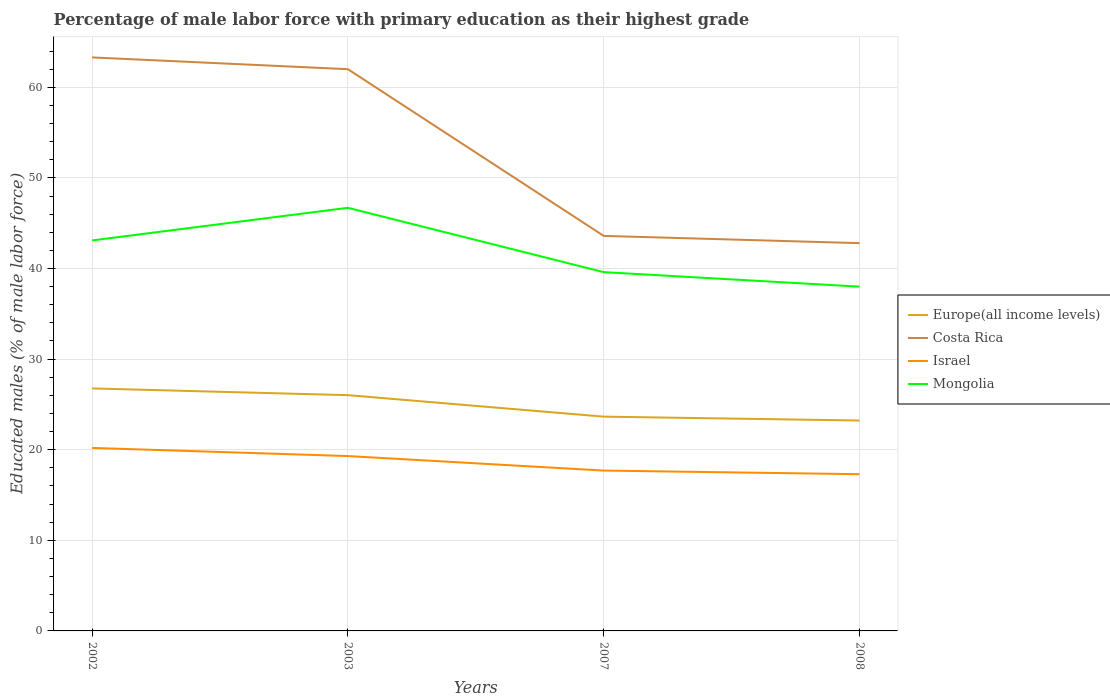How many different coloured lines are there?
Provide a short and direct response. 4. Across all years, what is the maximum percentage of male labor force with primary education in Costa Rica?
Your response must be concise. 42.8. In which year was the percentage of male labor force with primary education in Mongolia maximum?
Ensure brevity in your answer.  2008. What is the total percentage of male labor force with primary education in Mongolia in the graph?
Offer a very short reply. -3.6. What is the difference between the highest and the second highest percentage of male labor force with primary education in Israel?
Make the answer very short. 2.9. Is the percentage of male labor force with primary education in Israel strictly greater than the percentage of male labor force with primary education in Costa Rica over the years?
Provide a short and direct response. Yes. How many years are there in the graph?
Offer a terse response. 4. What is the difference between two consecutive major ticks on the Y-axis?
Provide a short and direct response. 10. Are the values on the major ticks of Y-axis written in scientific E-notation?
Your answer should be compact. No. Does the graph contain any zero values?
Your response must be concise. No. Does the graph contain grids?
Provide a short and direct response. Yes. How many legend labels are there?
Ensure brevity in your answer.  4. What is the title of the graph?
Your answer should be very brief. Percentage of male labor force with primary education as their highest grade. Does "Europe(developing only)" appear as one of the legend labels in the graph?
Offer a very short reply. No. What is the label or title of the Y-axis?
Keep it short and to the point. Educated males (% of male labor force). What is the Educated males (% of male labor force) of Europe(all income levels) in 2002?
Make the answer very short. 26.77. What is the Educated males (% of male labor force) in Costa Rica in 2002?
Your response must be concise. 63.3. What is the Educated males (% of male labor force) in Israel in 2002?
Your answer should be very brief. 20.2. What is the Educated males (% of male labor force) of Mongolia in 2002?
Offer a very short reply. 43.1. What is the Educated males (% of male labor force) in Europe(all income levels) in 2003?
Give a very brief answer. 26.02. What is the Educated males (% of male labor force) in Costa Rica in 2003?
Provide a short and direct response. 62. What is the Educated males (% of male labor force) of Israel in 2003?
Give a very brief answer. 19.3. What is the Educated males (% of male labor force) in Mongolia in 2003?
Offer a terse response. 46.7. What is the Educated males (% of male labor force) in Europe(all income levels) in 2007?
Provide a succinct answer. 23.65. What is the Educated males (% of male labor force) in Costa Rica in 2007?
Give a very brief answer. 43.6. What is the Educated males (% of male labor force) in Israel in 2007?
Your response must be concise. 17.7. What is the Educated males (% of male labor force) in Mongolia in 2007?
Provide a short and direct response. 39.6. What is the Educated males (% of male labor force) in Europe(all income levels) in 2008?
Keep it short and to the point. 23.22. What is the Educated males (% of male labor force) of Costa Rica in 2008?
Your answer should be compact. 42.8. What is the Educated males (% of male labor force) of Israel in 2008?
Make the answer very short. 17.3. What is the Educated males (% of male labor force) of Mongolia in 2008?
Give a very brief answer. 38. Across all years, what is the maximum Educated males (% of male labor force) of Europe(all income levels)?
Provide a short and direct response. 26.77. Across all years, what is the maximum Educated males (% of male labor force) in Costa Rica?
Offer a very short reply. 63.3. Across all years, what is the maximum Educated males (% of male labor force) of Israel?
Provide a succinct answer. 20.2. Across all years, what is the maximum Educated males (% of male labor force) of Mongolia?
Offer a very short reply. 46.7. Across all years, what is the minimum Educated males (% of male labor force) of Europe(all income levels)?
Give a very brief answer. 23.22. Across all years, what is the minimum Educated males (% of male labor force) in Costa Rica?
Your answer should be compact. 42.8. Across all years, what is the minimum Educated males (% of male labor force) in Israel?
Provide a succinct answer. 17.3. Across all years, what is the minimum Educated males (% of male labor force) of Mongolia?
Provide a short and direct response. 38. What is the total Educated males (% of male labor force) of Europe(all income levels) in the graph?
Ensure brevity in your answer.  99.66. What is the total Educated males (% of male labor force) of Costa Rica in the graph?
Your response must be concise. 211.7. What is the total Educated males (% of male labor force) of Israel in the graph?
Provide a short and direct response. 74.5. What is the total Educated males (% of male labor force) in Mongolia in the graph?
Your answer should be compact. 167.4. What is the difference between the Educated males (% of male labor force) in Europe(all income levels) in 2002 and that in 2003?
Your response must be concise. 0.74. What is the difference between the Educated males (% of male labor force) in Mongolia in 2002 and that in 2003?
Your answer should be compact. -3.6. What is the difference between the Educated males (% of male labor force) in Europe(all income levels) in 2002 and that in 2007?
Offer a terse response. 3.11. What is the difference between the Educated males (% of male labor force) of Costa Rica in 2002 and that in 2007?
Give a very brief answer. 19.7. What is the difference between the Educated males (% of male labor force) of Israel in 2002 and that in 2007?
Provide a short and direct response. 2.5. What is the difference between the Educated males (% of male labor force) of Mongolia in 2002 and that in 2007?
Give a very brief answer. 3.5. What is the difference between the Educated males (% of male labor force) in Europe(all income levels) in 2002 and that in 2008?
Provide a short and direct response. 3.54. What is the difference between the Educated males (% of male labor force) of Costa Rica in 2002 and that in 2008?
Keep it short and to the point. 20.5. What is the difference between the Educated males (% of male labor force) in Mongolia in 2002 and that in 2008?
Offer a very short reply. 5.1. What is the difference between the Educated males (% of male labor force) in Europe(all income levels) in 2003 and that in 2007?
Keep it short and to the point. 2.37. What is the difference between the Educated males (% of male labor force) of Mongolia in 2003 and that in 2007?
Offer a very short reply. 7.1. What is the difference between the Educated males (% of male labor force) in Europe(all income levels) in 2003 and that in 2008?
Provide a short and direct response. 2.8. What is the difference between the Educated males (% of male labor force) in Mongolia in 2003 and that in 2008?
Your answer should be very brief. 8.7. What is the difference between the Educated males (% of male labor force) of Europe(all income levels) in 2007 and that in 2008?
Offer a terse response. 0.43. What is the difference between the Educated males (% of male labor force) in Europe(all income levels) in 2002 and the Educated males (% of male labor force) in Costa Rica in 2003?
Ensure brevity in your answer.  -35.23. What is the difference between the Educated males (% of male labor force) of Europe(all income levels) in 2002 and the Educated males (% of male labor force) of Israel in 2003?
Make the answer very short. 7.47. What is the difference between the Educated males (% of male labor force) of Europe(all income levels) in 2002 and the Educated males (% of male labor force) of Mongolia in 2003?
Offer a very short reply. -19.93. What is the difference between the Educated males (% of male labor force) in Costa Rica in 2002 and the Educated males (% of male labor force) in Mongolia in 2003?
Make the answer very short. 16.6. What is the difference between the Educated males (% of male labor force) in Israel in 2002 and the Educated males (% of male labor force) in Mongolia in 2003?
Your answer should be very brief. -26.5. What is the difference between the Educated males (% of male labor force) of Europe(all income levels) in 2002 and the Educated males (% of male labor force) of Costa Rica in 2007?
Your response must be concise. -16.83. What is the difference between the Educated males (% of male labor force) in Europe(all income levels) in 2002 and the Educated males (% of male labor force) in Israel in 2007?
Make the answer very short. 9.07. What is the difference between the Educated males (% of male labor force) of Europe(all income levels) in 2002 and the Educated males (% of male labor force) of Mongolia in 2007?
Your answer should be very brief. -12.83. What is the difference between the Educated males (% of male labor force) of Costa Rica in 2002 and the Educated males (% of male labor force) of Israel in 2007?
Your answer should be compact. 45.6. What is the difference between the Educated males (% of male labor force) in Costa Rica in 2002 and the Educated males (% of male labor force) in Mongolia in 2007?
Ensure brevity in your answer.  23.7. What is the difference between the Educated males (% of male labor force) in Israel in 2002 and the Educated males (% of male labor force) in Mongolia in 2007?
Your answer should be compact. -19.4. What is the difference between the Educated males (% of male labor force) in Europe(all income levels) in 2002 and the Educated males (% of male labor force) in Costa Rica in 2008?
Keep it short and to the point. -16.03. What is the difference between the Educated males (% of male labor force) in Europe(all income levels) in 2002 and the Educated males (% of male labor force) in Israel in 2008?
Ensure brevity in your answer.  9.47. What is the difference between the Educated males (% of male labor force) of Europe(all income levels) in 2002 and the Educated males (% of male labor force) of Mongolia in 2008?
Offer a terse response. -11.23. What is the difference between the Educated males (% of male labor force) of Costa Rica in 2002 and the Educated males (% of male labor force) of Israel in 2008?
Make the answer very short. 46. What is the difference between the Educated males (% of male labor force) of Costa Rica in 2002 and the Educated males (% of male labor force) of Mongolia in 2008?
Make the answer very short. 25.3. What is the difference between the Educated males (% of male labor force) of Israel in 2002 and the Educated males (% of male labor force) of Mongolia in 2008?
Ensure brevity in your answer.  -17.8. What is the difference between the Educated males (% of male labor force) in Europe(all income levels) in 2003 and the Educated males (% of male labor force) in Costa Rica in 2007?
Make the answer very short. -17.58. What is the difference between the Educated males (% of male labor force) of Europe(all income levels) in 2003 and the Educated males (% of male labor force) of Israel in 2007?
Make the answer very short. 8.32. What is the difference between the Educated males (% of male labor force) in Europe(all income levels) in 2003 and the Educated males (% of male labor force) in Mongolia in 2007?
Offer a very short reply. -13.58. What is the difference between the Educated males (% of male labor force) in Costa Rica in 2003 and the Educated males (% of male labor force) in Israel in 2007?
Make the answer very short. 44.3. What is the difference between the Educated males (% of male labor force) in Costa Rica in 2003 and the Educated males (% of male labor force) in Mongolia in 2007?
Make the answer very short. 22.4. What is the difference between the Educated males (% of male labor force) of Israel in 2003 and the Educated males (% of male labor force) of Mongolia in 2007?
Provide a succinct answer. -20.3. What is the difference between the Educated males (% of male labor force) of Europe(all income levels) in 2003 and the Educated males (% of male labor force) of Costa Rica in 2008?
Give a very brief answer. -16.78. What is the difference between the Educated males (% of male labor force) in Europe(all income levels) in 2003 and the Educated males (% of male labor force) in Israel in 2008?
Your answer should be compact. 8.72. What is the difference between the Educated males (% of male labor force) of Europe(all income levels) in 2003 and the Educated males (% of male labor force) of Mongolia in 2008?
Give a very brief answer. -11.98. What is the difference between the Educated males (% of male labor force) in Costa Rica in 2003 and the Educated males (% of male labor force) in Israel in 2008?
Offer a very short reply. 44.7. What is the difference between the Educated males (% of male labor force) of Israel in 2003 and the Educated males (% of male labor force) of Mongolia in 2008?
Ensure brevity in your answer.  -18.7. What is the difference between the Educated males (% of male labor force) of Europe(all income levels) in 2007 and the Educated males (% of male labor force) of Costa Rica in 2008?
Your response must be concise. -19.15. What is the difference between the Educated males (% of male labor force) in Europe(all income levels) in 2007 and the Educated males (% of male labor force) in Israel in 2008?
Your answer should be compact. 6.35. What is the difference between the Educated males (% of male labor force) of Europe(all income levels) in 2007 and the Educated males (% of male labor force) of Mongolia in 2008?
Keep it short and to the point. -14.35. What is the difference between the Educated males (% of male labor force) of Costa Rica in 2007 and the Educated males (% of male labor force) of Israel in 2008?
Keep it short and to the point. 26.3. What is the difference between the Educated males (% of male labor force) of Costa Rica in 2007 and the Educated males (% of male labor force) of Mongolia in 2008?
Your response must be concise. 5.6. What is the difference between the Educated males (% of male labor force) of Israel in 2007 and the Educated males (% of male labor force) of Mongolia in 2008?
Your answer should be compact. -20.3. What is the average Educated males (% of male labor force) in Europe(all income levels) per year?
Give a very brief answer. 24.92. What is the average Educated males (% of male labor force) in Costa Rica per year?
Provide a succinct answer. 52.92. What is the average Educated males (% of male labor force) in Israel per year?
Offer a terse response. 18.62. What is the average Educated males (% of male labor force) in Mongolia per year?
Ensure brevity in your answer.  41.85. In the year 2002, what is the difference between the Educated males (% of male labor force) in Europe(all income levels) and Educated males (% of male labor force) in Costa Rica?
Your answer should be very brief. -36.53. In the year 2002, what is the difference between the Educated males (% of male labor force) of Europe(all income levels) and Educated males (% of male labor force) of Israel?
Your answer should be compact. 6.57. In the year 2002, what is the difference between the Educated males (% of male labor force) in Europe(all income levels) and Educated males (% of male labor force) in Mongolia?
Ensure brevity in your answer.  -16.33. In the year 2002, what is the difference between the Educated males (% of male labor force) in Costa Rica and Educated males (% of male labor force) in Israel?
Provide a succinct answer. 43.1. In the year 2002, what is the difference between the Educated males (% of male labor force) in Costa Rica and Educated males (% of male labor force) in Mongolia?
Offer a terse response. 20.2. In the year 2002, what is the difference between the Educated males (% of male labor force) in Israel and Educated males (% of male labor force) in Mongolia?
Your answer should be compact. -22.9. In the year 2003, what is the difference between the Educated males (% of male labor force) in Europe(all income levels) and Educated males (% of male labor force) in Costa Rica?
Your answer should be very brief. -35.98. In the year 2003, what is the difference between the Educated males (% of male labor force) in Europe(all income levels) and Educated males (% of male labor force) in Israel?
Make the answer very short. 6.72. In the year 2003, what is the difference between the Educated males (% of male labor force) in Europe(all income levels) and Educated males (% of male labor force) in Mongolia?
Your answer should be compact. -20.68. In the year 2003, what is the difference between the Educated males (% of male labor force) of Costa Rica and Educated males (% of male labor force) of Israel?
Provide a succinct answer. 42.7. In the year 2003, what is the difference between the Educated males (% of male labor force) in Israel and Educated males (% of male labor force) in Mongolia?
Provide a succinct answer. -27.4. In the year 2007, what is the difference between the Educated males (% of male labor force) in Europe(all income levels) and Educated males (% of male labor force) in Costa Rica?
Your answer should be very brief. -19.95. In the year 2007, what is the difference between the Educated males (% of male labor force) in Europe(all income levels) and Educated males (% of male labor force) in Israel?
Offer a terse response. 5.95. In the year 2007, what is the difference between the Educated males (% of male labor force) of Europe(all income levels) and Educated males (% of male labor force) of Mongolia?
Give a very brief answer. -15.95. In the year 2007, what is the difference between the Educated males (% of male labor force) of Costa Rica and Educated males (% of male labor force) of Israel?
Provide a succinct answer. 25.9. In the year 2007, what is the difference between the Educated males (% of male labor force) in Costa Rica and Educated males (% of male labor force) in Mongolia?
Ensure brevity in your answer.  4. In the year 2007, what is the difference between the Educated males (% of male labor force) of Israel and Educated males (% of male labor force) of Mongolia?
Your answer should be compact. -21.9. In the year 2008, what is the difference between the Educated males (% of male labor force) of Europe(all income levels) and Educated males (% of male labor force) of Costa Rica?
Provide a succinct answer. -19.58. In the year 2008, what is the difference between the Educated males (% of male labor force) of Europe(all income levels) and Educated males (% of male labor force) of Israel?
Offer a very short reply. 5.92. In the year 2008, what is the difference between the Educated males (% of male labor force) of Europe(all income levels) and Educated males (% of male labor force) of Mongolia?
Offer a terse response. -14.78. In the year 2008, what is the difference between the Educated males (% of male labor force) in Israel and Educated males (% of male labor force) in Mongolia?
Offer a terse response. -20.7. What is the ratio of the Educated males (% of male labor force) of Europe(all income levels) in 2002 to that in 2003?
Your answer should be very brief. 1.03. What is the ratio of the Educated males (% of male labor force) in Israel in 2002 to that in 2003?
Provide a short and direct response. 1.05. What is the ratio of the Educated males (% of male labor force) in Mongolia in 2002 to that in 2003?
Ensure brevity in your answer.  0.92. What is the ratio of the Educated males (% of male labor force) in Europe(all income levels) in 2002 to that in 2007?
Your answer should be very brief. 1.13. What is the ratio of the Educated males (% of male labor force) of Costa Rica in 2002 to that in 2007?
Provide a succinct answer. 1.45. What is the ratio of the Educated males (% of male labor force) in Israel in 2002 to that in 2007?
Ensure brevity in your answer.  1.14. What is the ratio of the Educated males (% of male labor force) in Mongolia in 2002 to that in 2007?
Provide a succinct answer. 1.09. What is the ratio of the Educated males (% of male labor force) in Europe(all income levels) in 2002 to that in 2008?
Give a very brief answer. 1.15. What is the ratio of the Educated males (% of male labor force) of Costa Rica in 2002 to that in 2008?
Offer a terse response. 1.48. What is the ratio of the Educated males (% of male labor force) in Israel in 2002 to that in 2008?
Provide a short and direct response. 1.17. What is the ratio of the Educated males (% of male labor force) of Mongolia in 2002 to that in 2008?
Provide a short and direct response. 1.13. What is the ratio of the Educated males (% of male labor force) of Europe(all income levels) in 2003 to that in 2007?
Keep it short and to the point. 1.1. What is the ratio of the Educated males (% of male labor force) of Costa Rica in 2003 to that in 2007?
Your response must be concise. 1.42. What is the ratio of the Educated males (% of male labor force) in Israel in 2003 to that in 2007?
Make the answer very short. 1.09. What is the ratio of the Educated males (% of male labor force) of Mongolia in 2003 to that in 2007?
Your answer should be compact. 1.18. What is the ratio of the Educated males (% of male labor force) of Europe(all income levels) in 2003 to that in 2008?
Ensure brevity in your answer.  1.12. What is the ratio of the Educated males (% of male labor force) of Costa Rica in 2003 to that in 2008?
Your answer should be compact. 1.45. What is the ratio of the Educated males (% of male labor force) of Israel in 2003 to that in 2008?
Ensure brevity in your answer.  1.12. What is the ratio of the Educated males (% of male labor force) of Mongolia in 2003 to that in 2008?
Your answer should be very brief. 1.23. What is the ratio of the Educated males (% of male labor force) in Europe(all income levels) in 2007 to that in 2008?
Your answer should be compact. 1.02. What is the ratio of the Educated males (% of male labor force) of Costa Rica in 2007 to that in 2008?
Offer a very short reply. 1.02. What is the ratio of the Educated males (% of male labor force) in Israel in 2007 to that in 2008?
Provide a short and direct response. 1.02. What is the ratio of the Educated males (% of male labor force) of Mongolia in 2007 to that in 2008?
Give a very brief answer. 1.04. What is the difference between the highest and the second highest Educated males (% of male labor force) in Europe(all income levels)?
Offer a very short reply. 0.74. What is the difference between the highest and the second highest Educated males (% of male labor force) of Costa Rica?
Give a very brief answer. 1.3. What is the difference between the highest and the second highest Educated males (% of male labor force) in Israel?
Ensure brevity in your answer.  0.9. What is the difference between the highest and the second highest Educated males (% of male labor force) in Mongolia?
Offer a very short reply. 3.6. What is the difference between the highest and the lowest Educated males (% of male labor force) in Europe(all income levels)?
Give a very brief answer. 3.54. What is the difference between the highest and the lowest Educated males (% of male labor force) in Costa Rica?
Your answer should be compact. 20.5. What is the difference between the highest and the lowest Educated males (% of male labor force) of Israel?
Your response must be concise. 2.9. What is the difference between the highest and the lowest Educated males (% of male labor force) of Mongolia?
Provide a short and direct response. 8.7. 